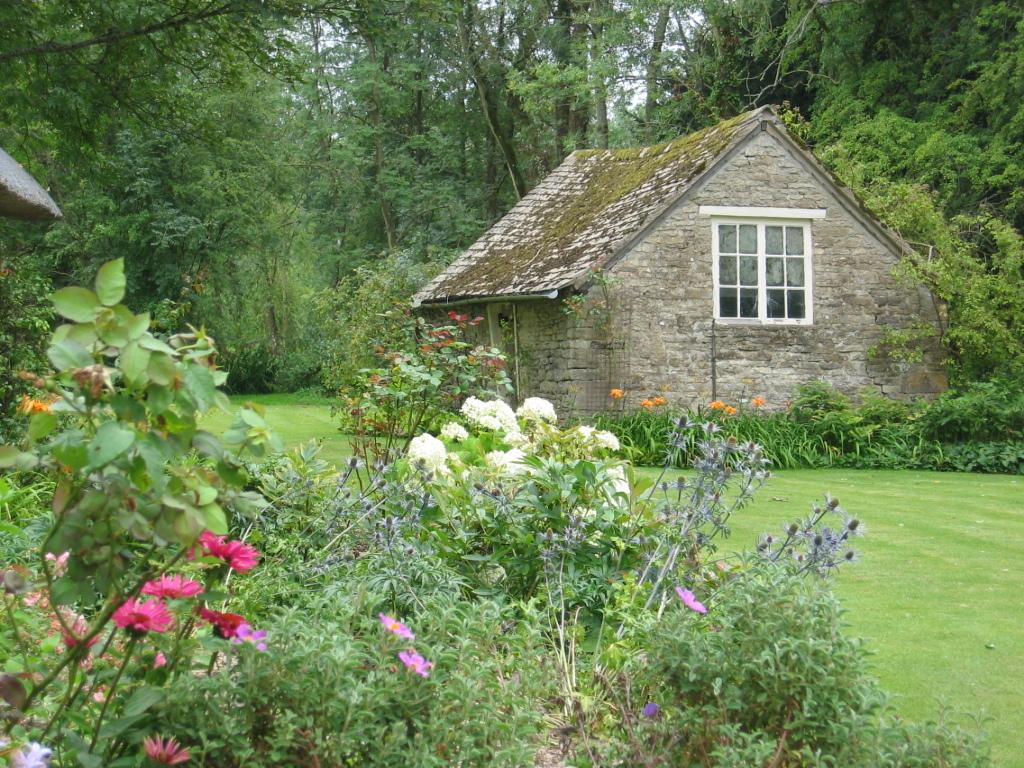What type of structure is present in the image? There is a home in the image. Where is the home located? The home is situated in a back area. What type of vegetation can be seen in the image? There are plants and trees in the image. What type of terrain is visible in the image? The grassland is visible in the image. What type of record can be seen being played in the image? There is no record present in the image. What type of bit is being used to transport the home in the image? There is no transportation of the home depicted in the image. 